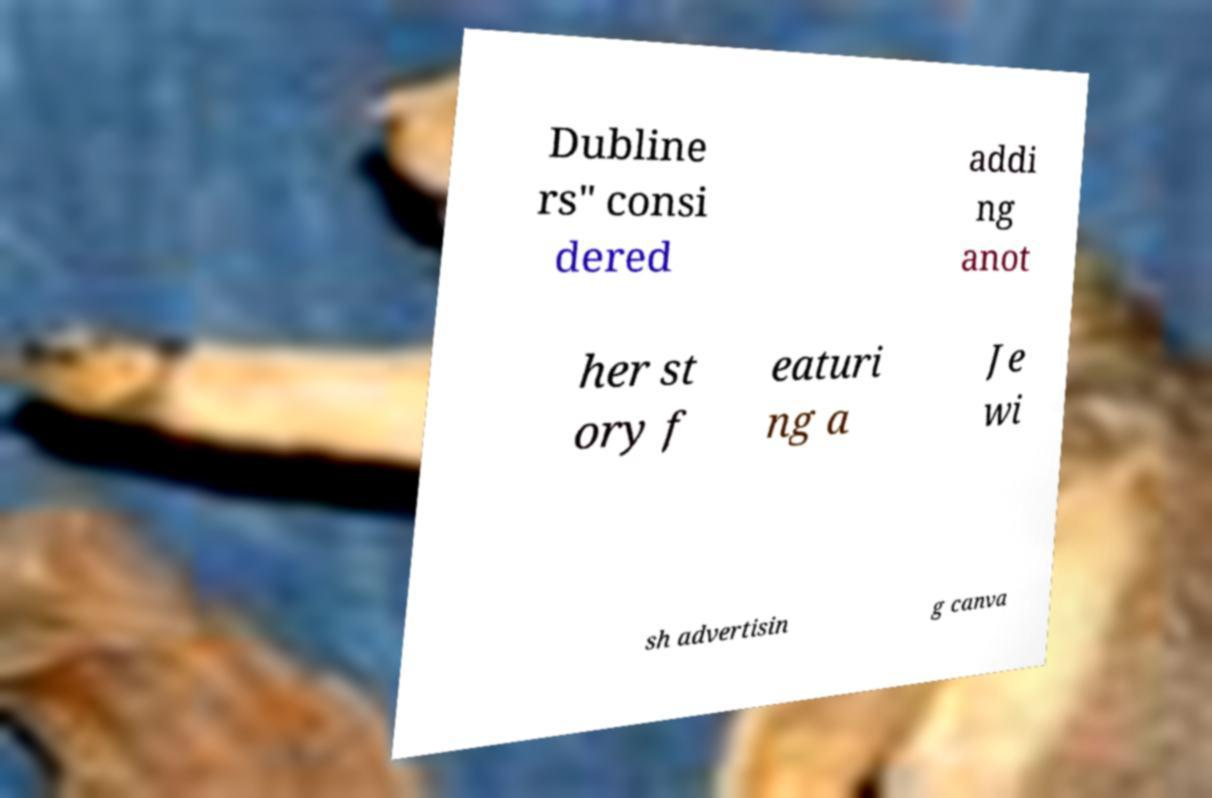Please identify and transcribe the text found in this image. Dubline rs" consi dered addi ng anot her st ory f eaturi ng a Je wi sh advertisin g canva 